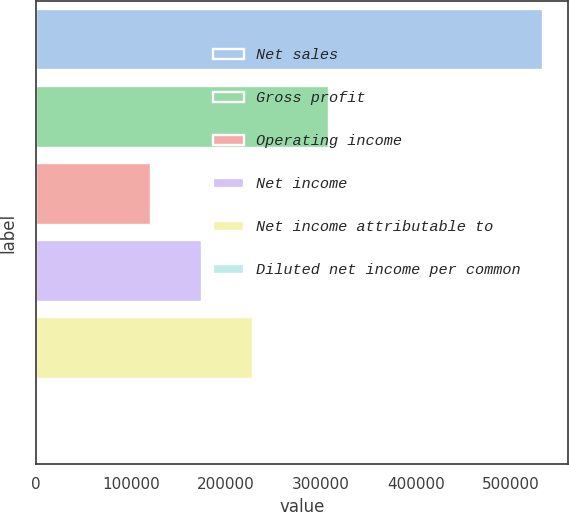Convert chart to OTSL. <chart><loc_0><loc_0><loc_500><loc_500><bar_chart><fcel>Net sales<fcel>Gross profit<fcel>Operating income<fcel>Net income<fcel>Net income attributable to<fcel>Diluted net income per common<nl><fcel>533952<fcel>309017<fcel>121319<fcel>174714<fcel>228109<fcel>0.6<nl></chart> 